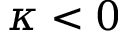Convert formula to latex. <formula><loc_0><loc_0><loc_500><loc_500>\kappa < 0</formula> 